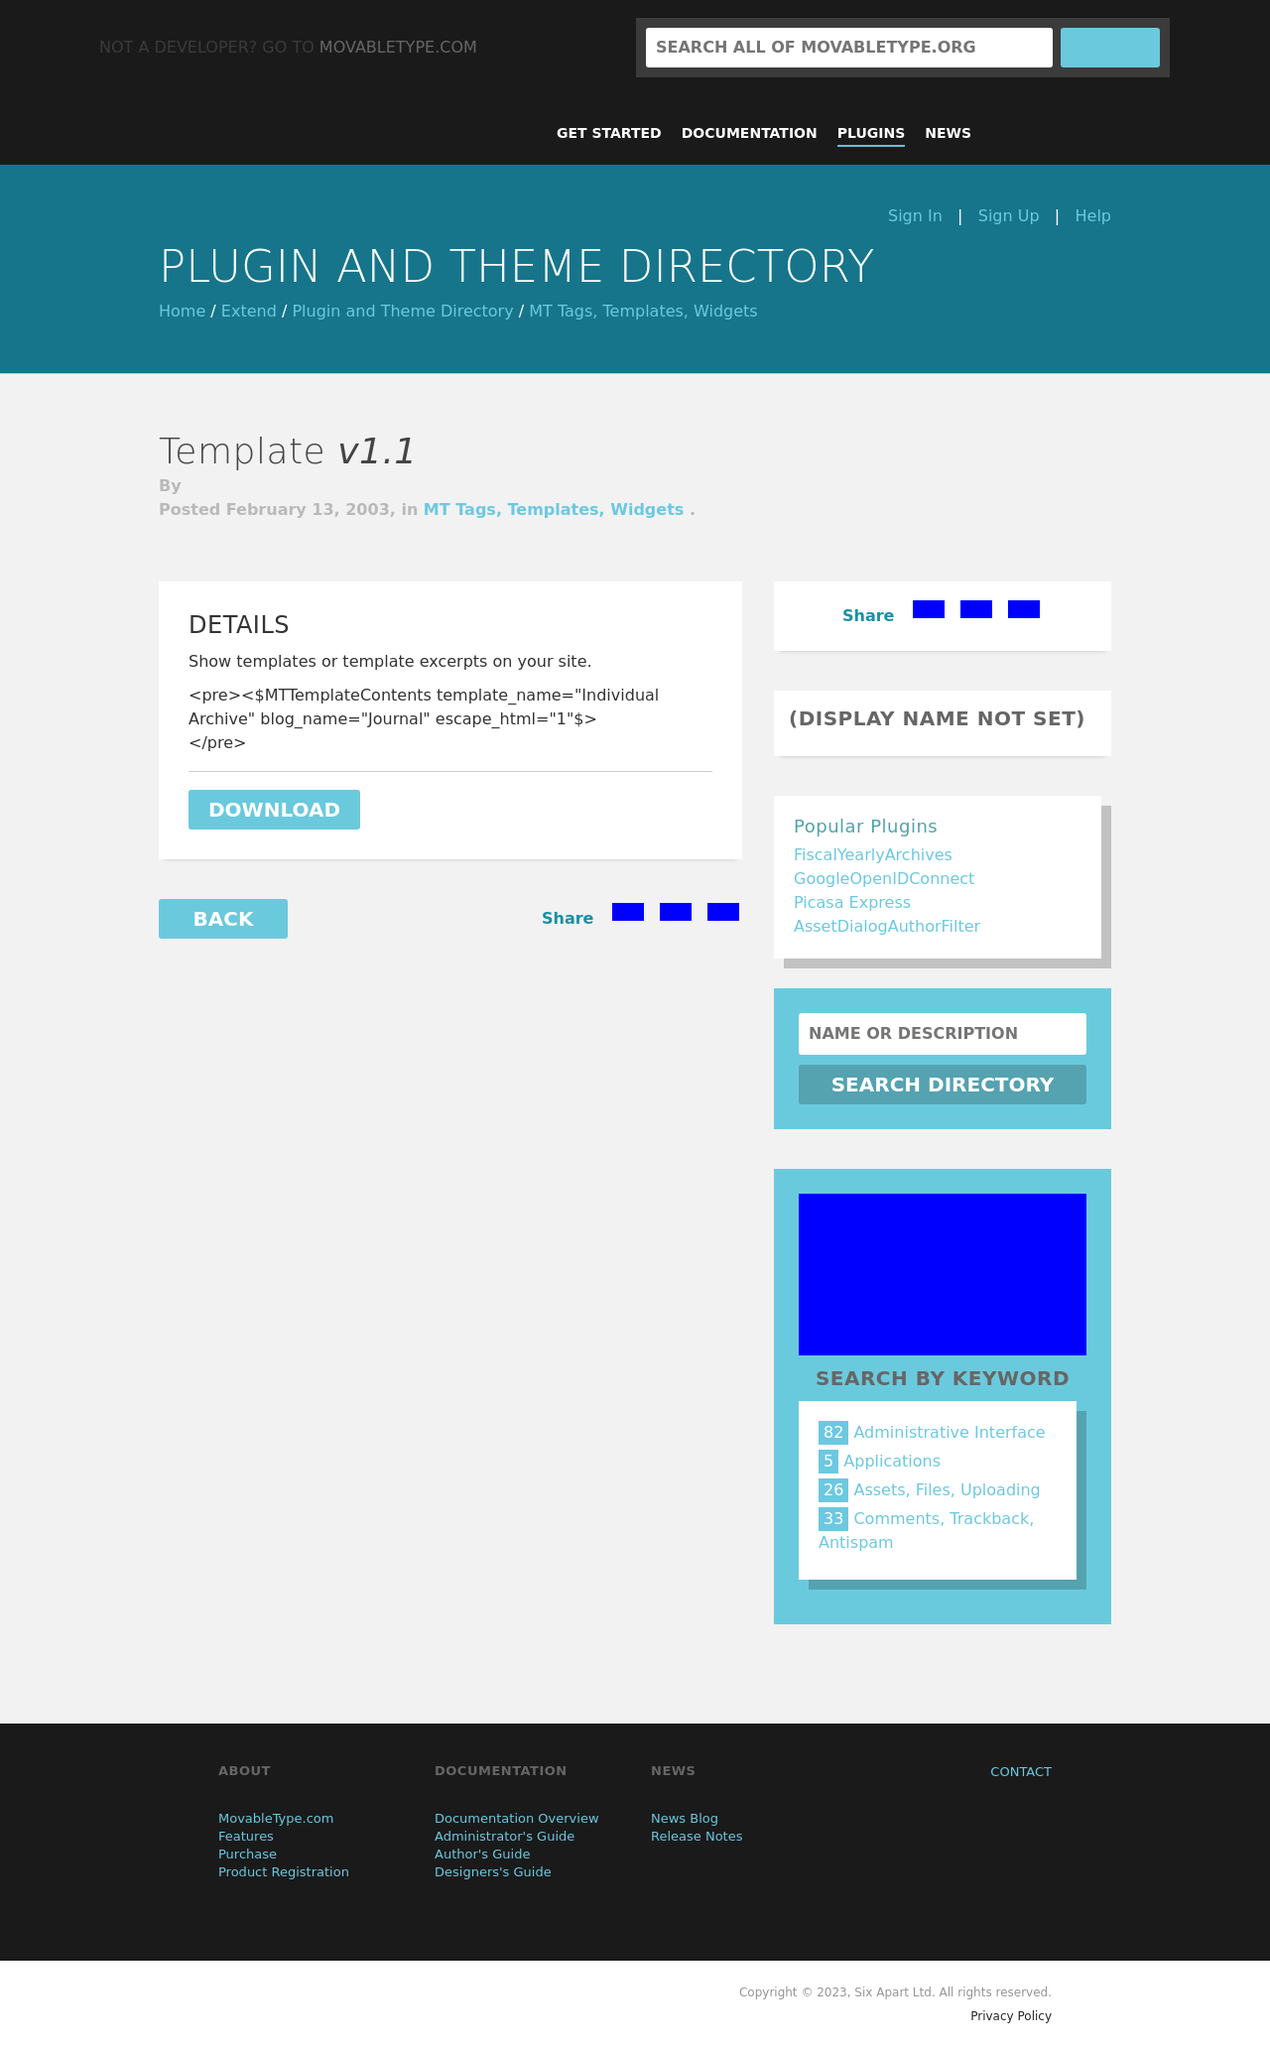Can you guide me in creating a similar layout to the image shown using HTML? Sure! The layout depicted in the image can be created using a combination of <div> elements for structure, alongside semantic HTML5 elements. You'll have a <header> for the top section, followed by <nav> for the navigation links. Use <main> for the central plugin directory detail, incorporating <article> for the post, and <aside> for the sidebar with the 'Popular Plugins'. Wrap the bottom content in a <footer>. Don’t forget to use responsive design techniques such as media queries in your CSS to ensure the layout adapts well to different screen sizes. 